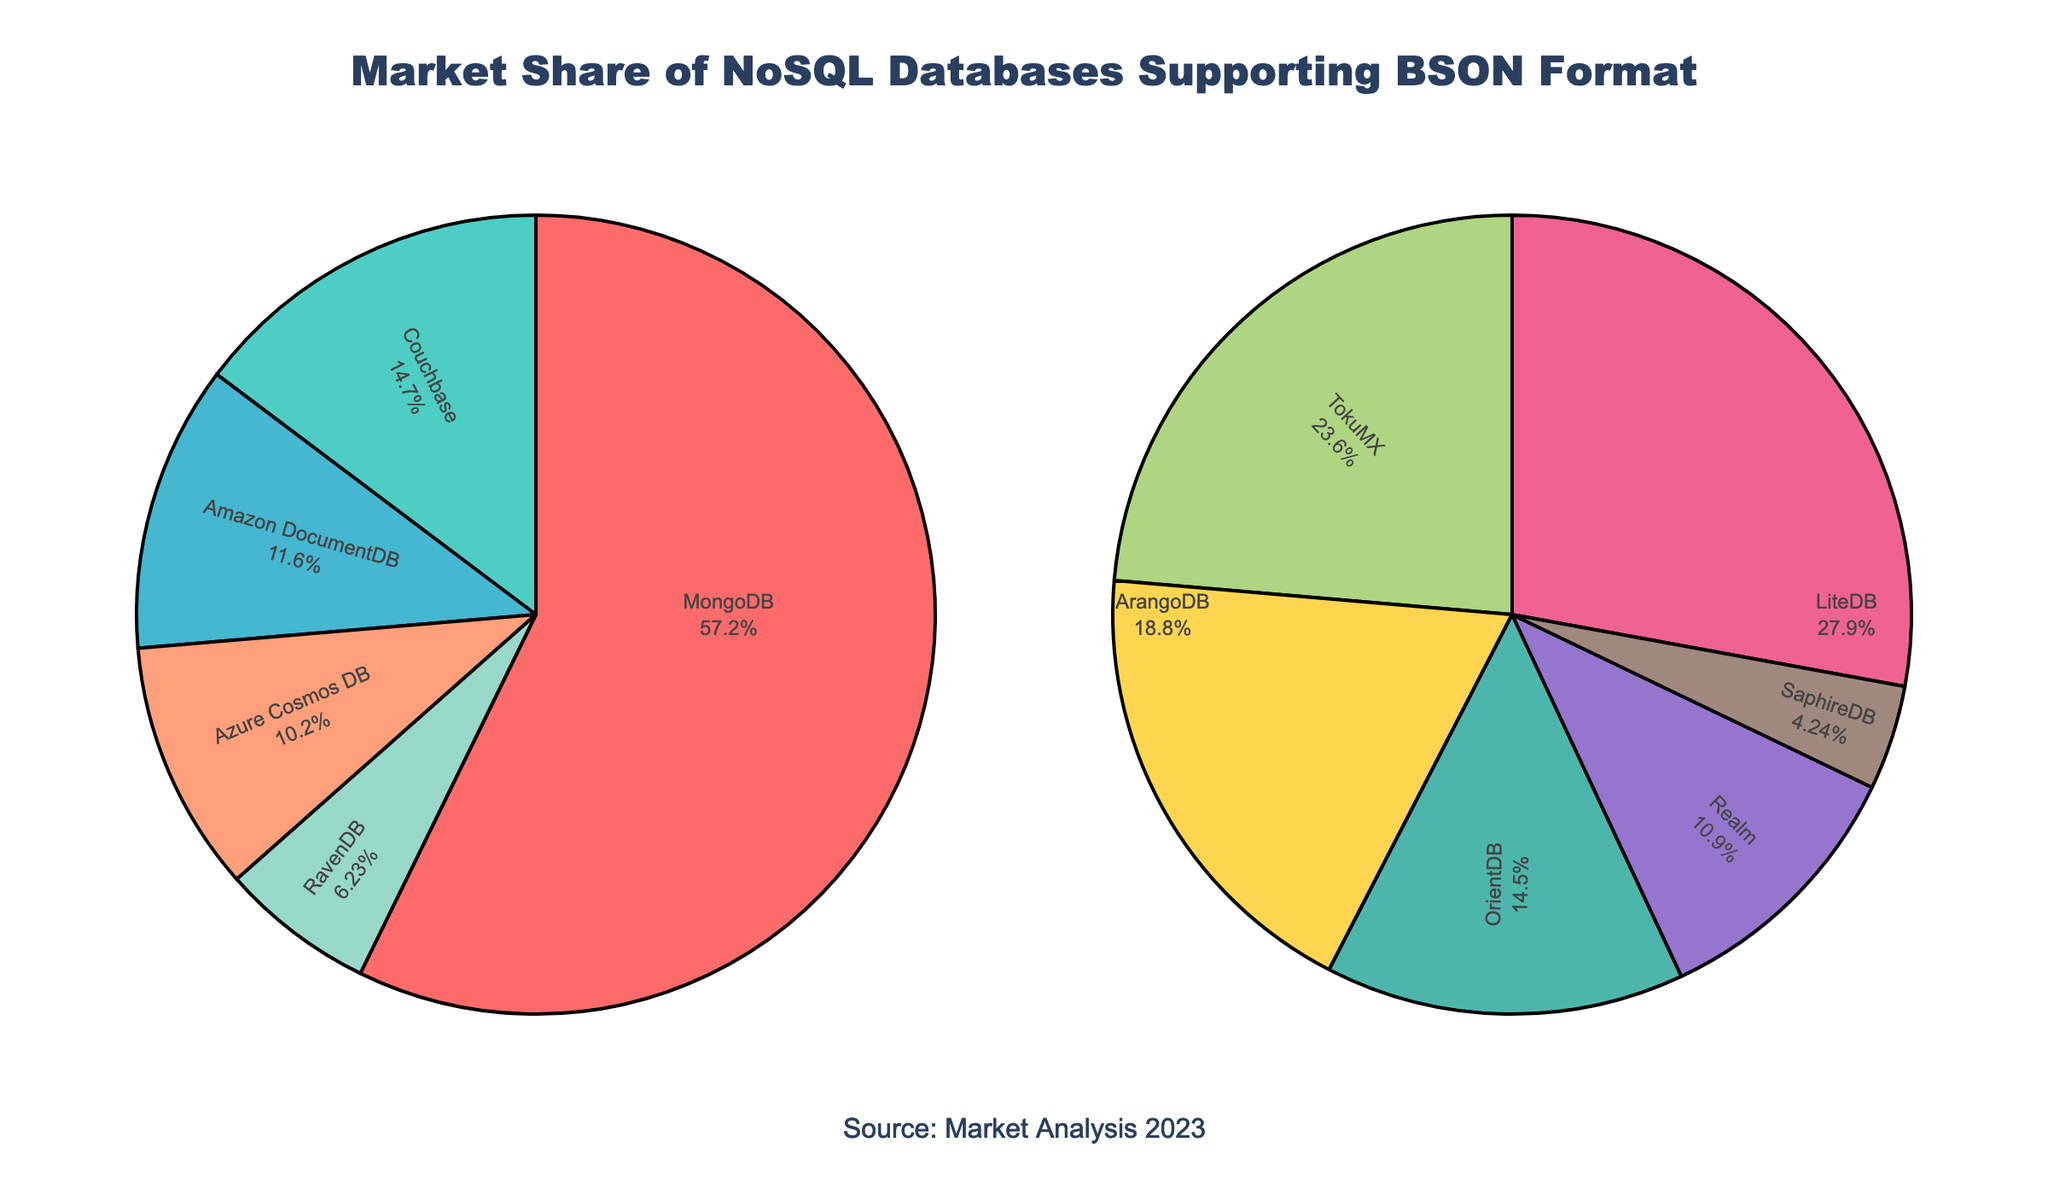What's the market share of the database with the largest market share? MongoDB is the database with the largest market share, which is shown as 47.8% in the pie chart. This can be directly read from the proportion of the pie chart.
Answer: 47.8% How much more market share does MongoDB have compared to Couchbase? The market share of MongoDB is 47.8%, and the market share of Couchbase is 12.3%. The difference is calculated as 47.8% - 12.3% = 35.5%.
Answer: 35.5% Which databases are grouped in the second pie chart? The second pie chart shows databases with less than the top 5 market shares. These databases are LiteDB, TokuMX, ArangoDB, OrientDB, Realm, and SaphireDB.
Answer: LiteDB, TokuMX, ArangoDB, OrientDB, Realm, SaphireDB What is the combined market share of the top 5 NoSQL databases? The top 5 NoSQL databases and their market shares are MongoDB (47.8%), Couchbase (12.3%), Amazon DocumentDB (9.7%), Azure Cosmos DB (8.5%), and RavenDB (5.2%). The combined market share is calculated as 47.8% + 12.3% + 9.7% + 8.5% + 5.2% = 83.5%.
Answer: 83.5% Which NoSQL database has the smallest market share and what is it? The database with the smallest market share is SaphireDB, with a market share of 0.7%. This is indicated by the smallest portion of the second pie chart.
Answer: SaphireDB, 0.7% How does the market share of Amazon DocumentDB compare relative to Azure Cosmos DB? Amazon DocumentDB has a market share of 9.7%, while Azure Cosmos DB has a market share of 8.5%. Amazon DocumentDB's market share is therefore greater than Azure Cosmos DB's by 9.7% - 8.5% = 1.2%.
Answer: 1.2% Which database has the highest market share among the ones depicted in the "Other NoSQL Databases" chart? The database with the highest market share among the ones depicted in the "Other NoSQL Databases" chart is LiteDB with a market share of 4.6%, indicated as the largest slice in the second pie chart.
Answer: LiteDB What is the total market share of databases with less than 5% market share each? Databases with less than 5% market share each are LiteDB (4.6%), TokuMX (3.9%), ArangoDB (3.1%), OrientDB (2.4%), Realm (1.8%), and SaphireDB (0.7%). The total market share is 4.6% + 3.9% + 3.1% + 2.4% + 1.8% + 0.7% = 16.5%.
Answer: 16.5% 